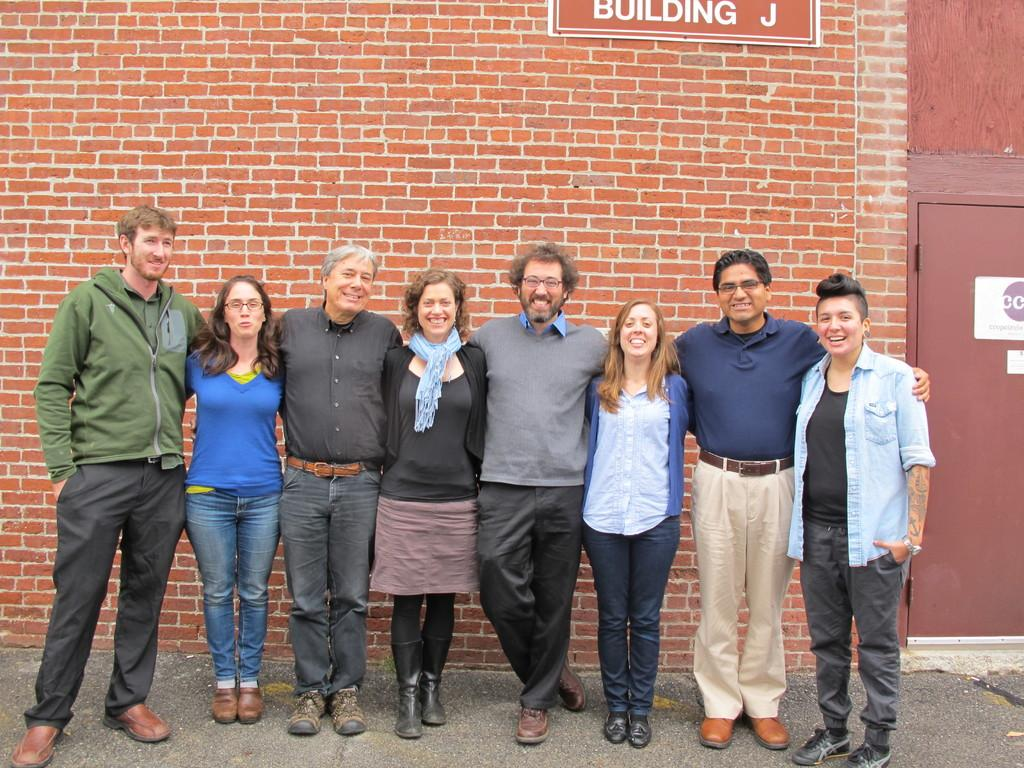What are the people in the image doing? The people in the image are standing in the center. What can be seen in the background of the image? There is a wall and a door visible in the background of the image. What type of tree is growing through the loaf of bread in the image? There is no tree or loaf of bread present in the image. 